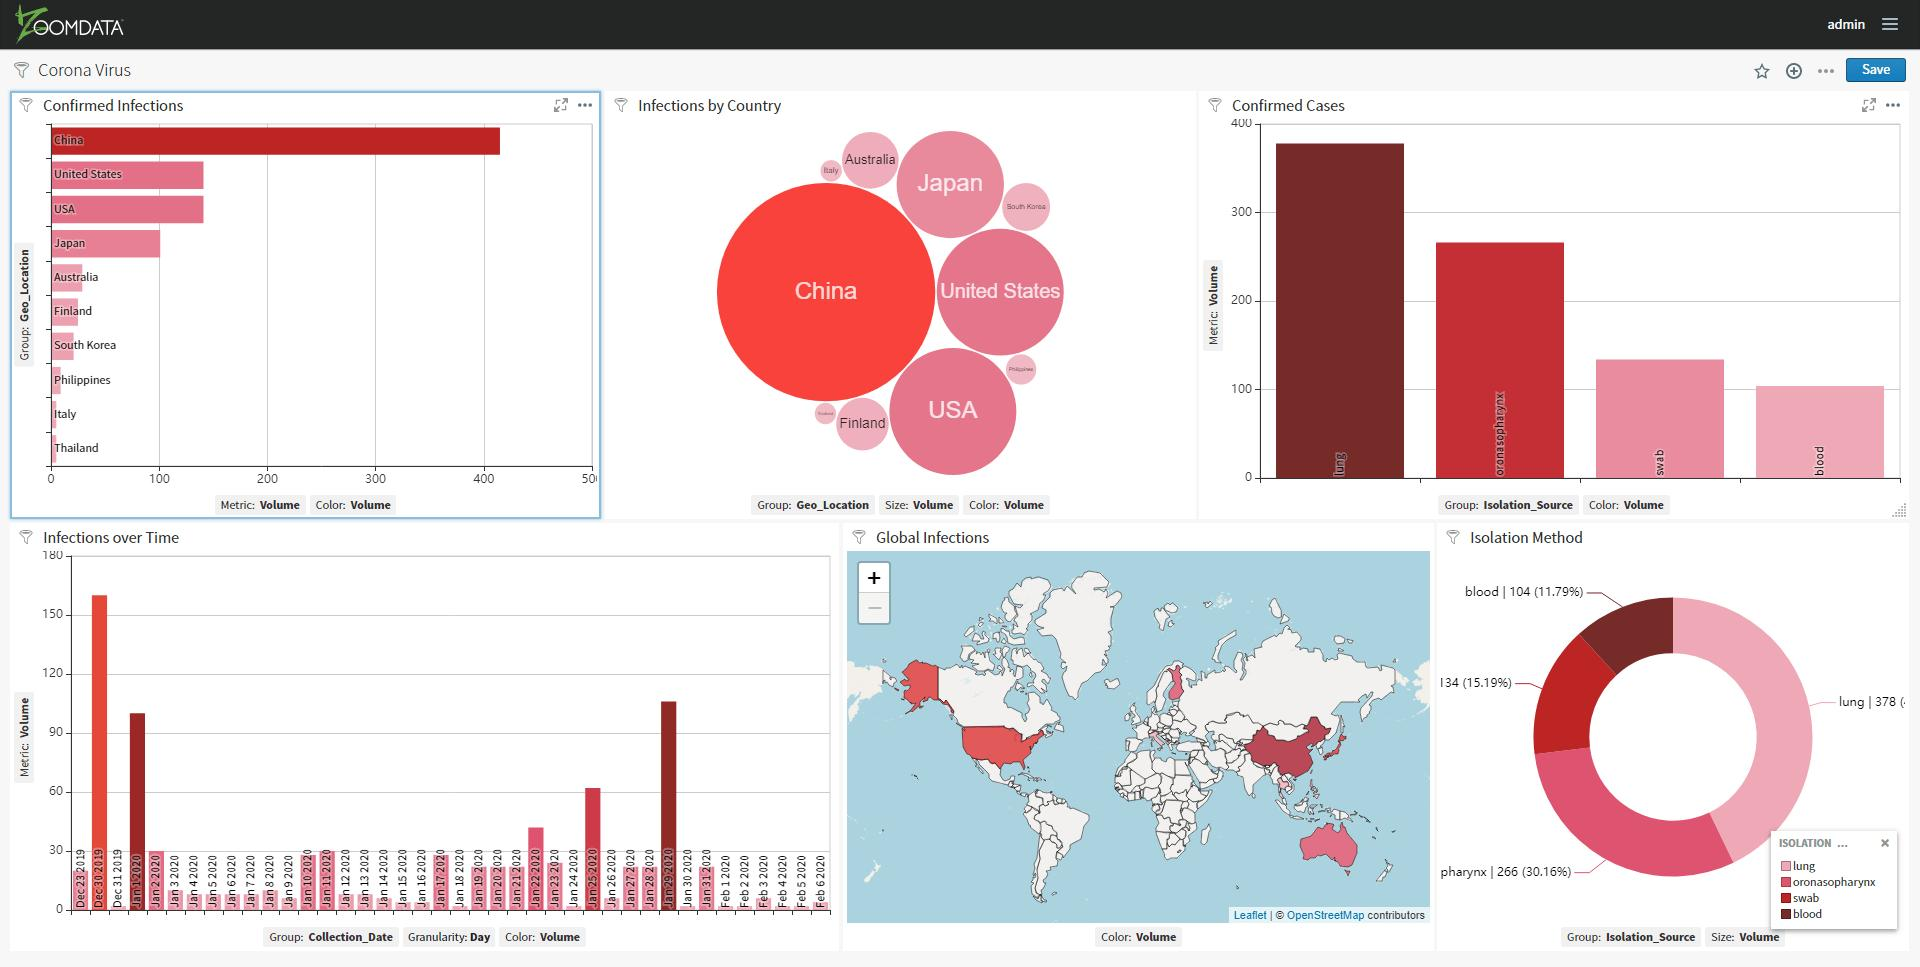Specify some key components in this picture. Four countries have reported cases of infection exceeding 100. China has the highest number of infections among all countries. Six countries have reported cases of COVID-19 with a total of fewer than 100 infections. 